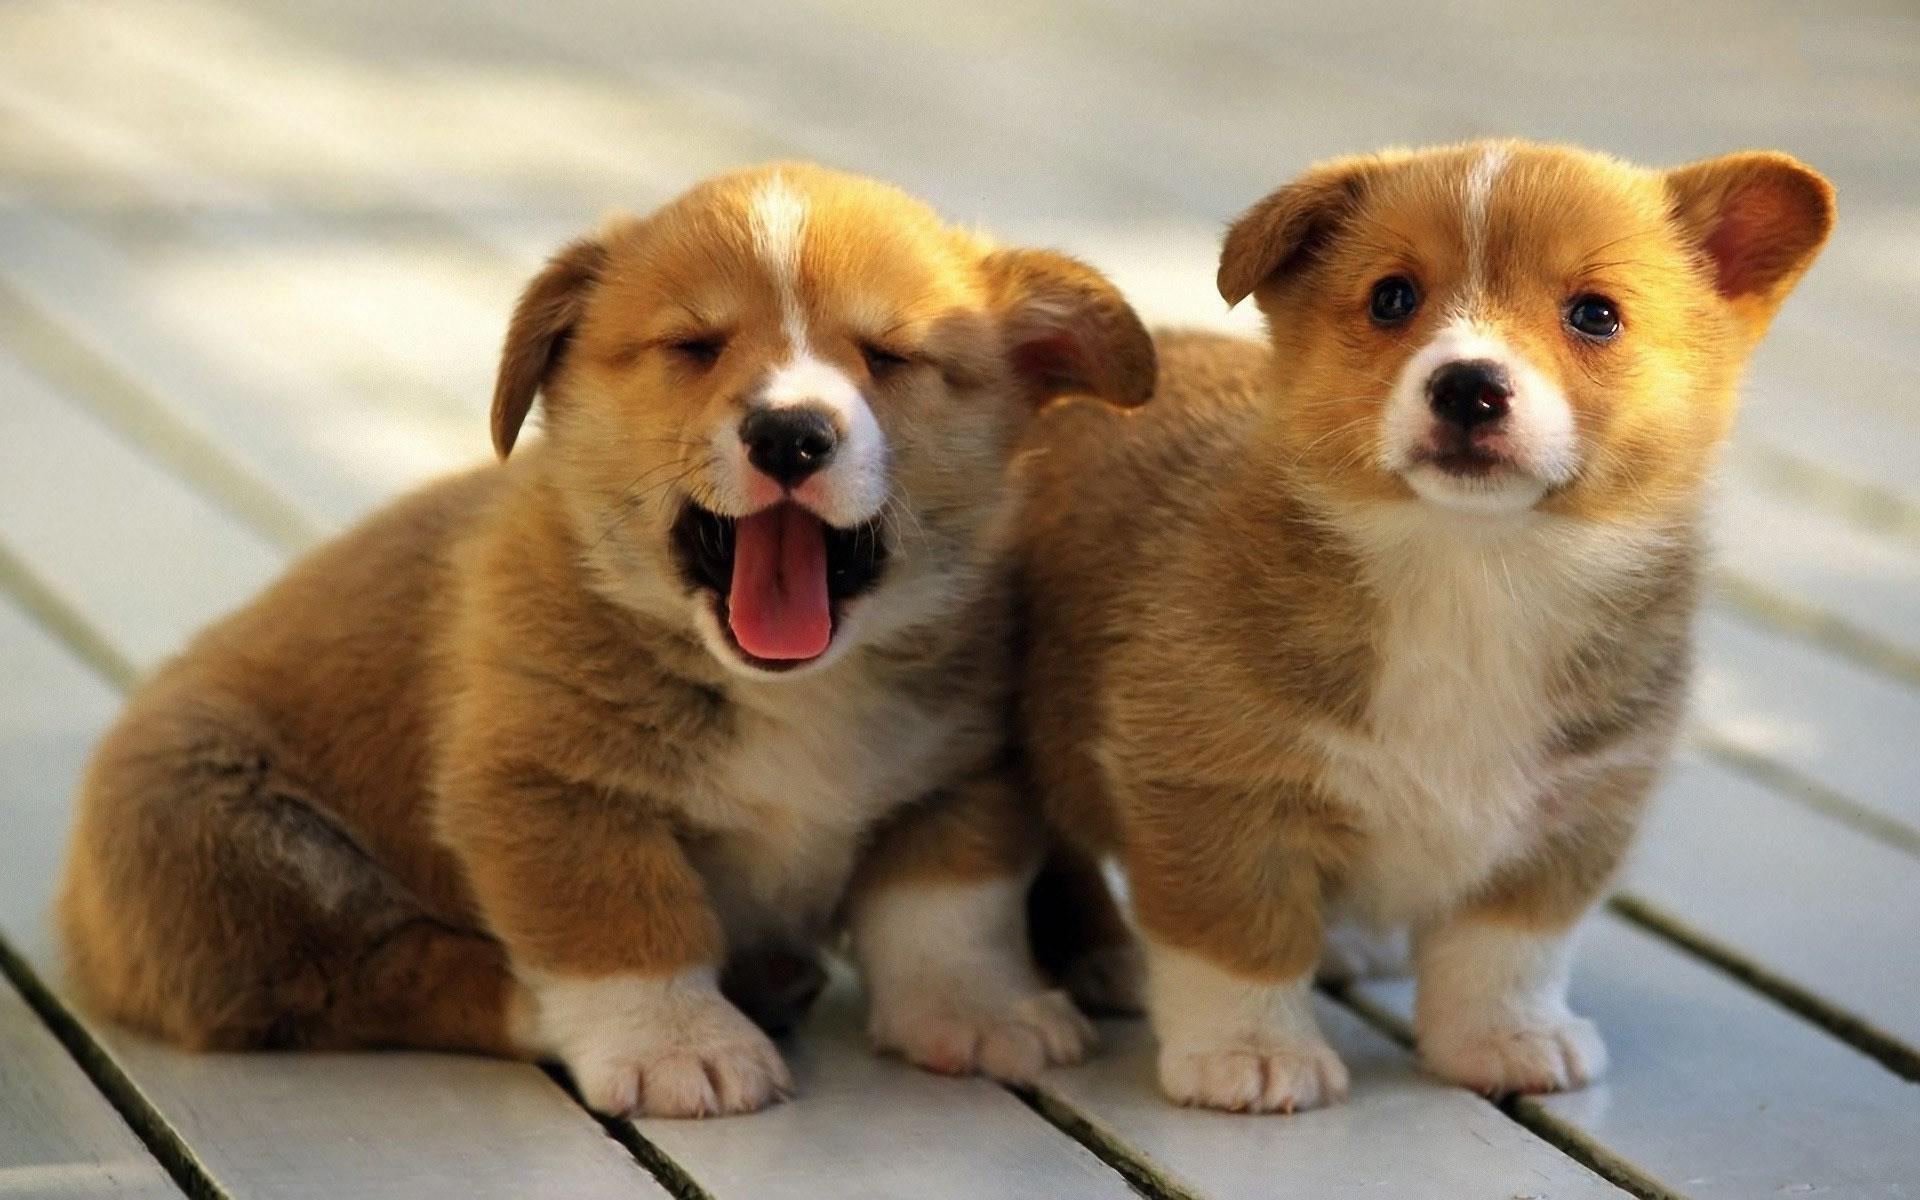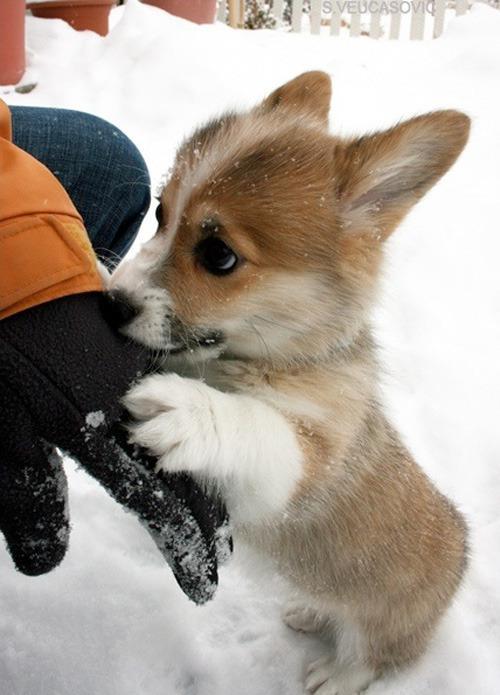The first image is the image on the left, the second image is the image on the right. For the images displayed, is the sentence "An image includes a corgi pup with one ear upright and the ear on the left flopping forward." factually correct? Answer yes or no. Yes. The first image is the image on the left, the second image is the image on the right. Assess this claim about the two images: "There's exactly two dogs in the left image.". Correct or not? Answer yes or no. Yes. 